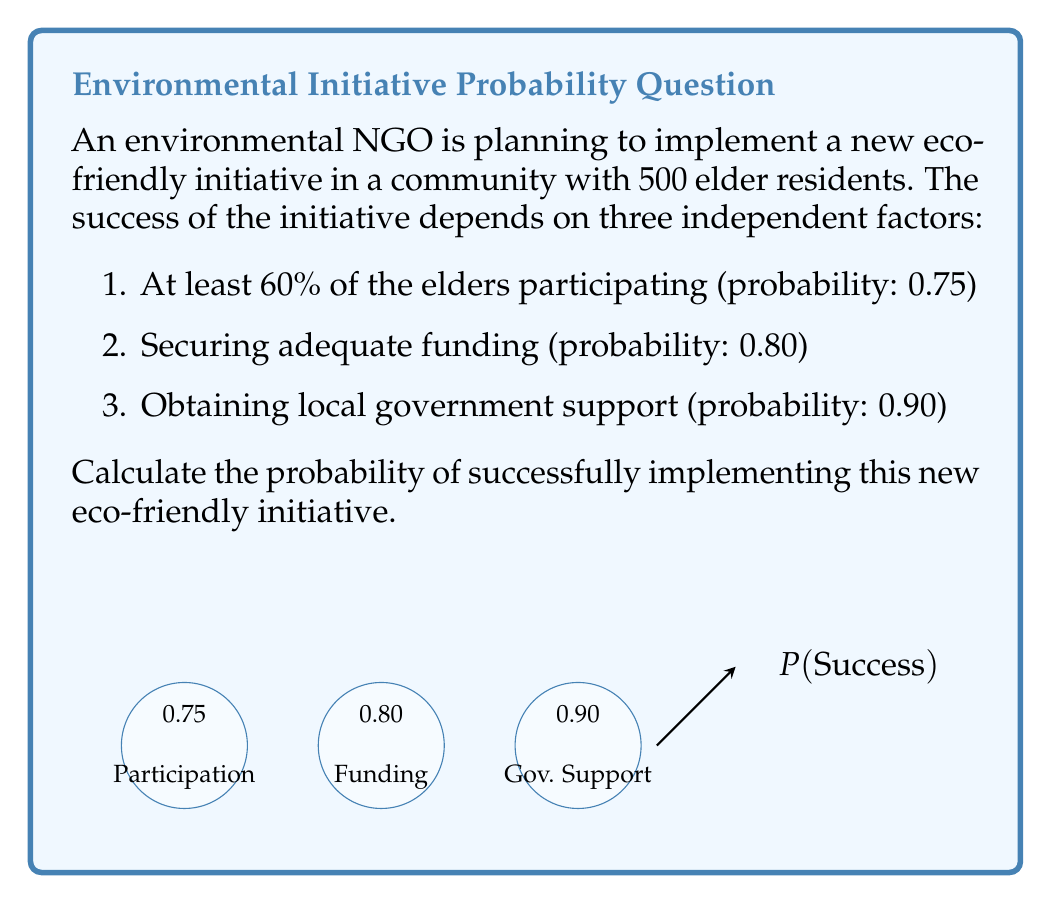Solve this math problem. To solve this problem, we need to use the multiplication rule for independent events. The initiative is successful only if all three independent factors occur simultaneously. Let's break it down step-by-step:

1) Let's define our events:
   A: At least 60% of elders participate
   B: Adequate funding is secured
   C: Local government support is obtained

2) Given probabilities:
   $P(A) = 0.75$
   $P(B) = 0.80$
   $P(C) = 0.90$

3) Since these events are independent, the probability of all three occurring together is the product of their individual probabilities:

   $P(\text{Success}) = P(A \cap B \cap C) = P(A) \times P(B) \times P(C)$

4) Substituting the values:

   $P(\text{Success}) = 0.75 \times 0.80 \times 0.90$

5) Calculating:

   $P(\text{Success}) = 0.54$

Therefore, the probability of successfully implementing the new eco-friendly initiative is 0.54 or 54%.
Answer: 0.54 